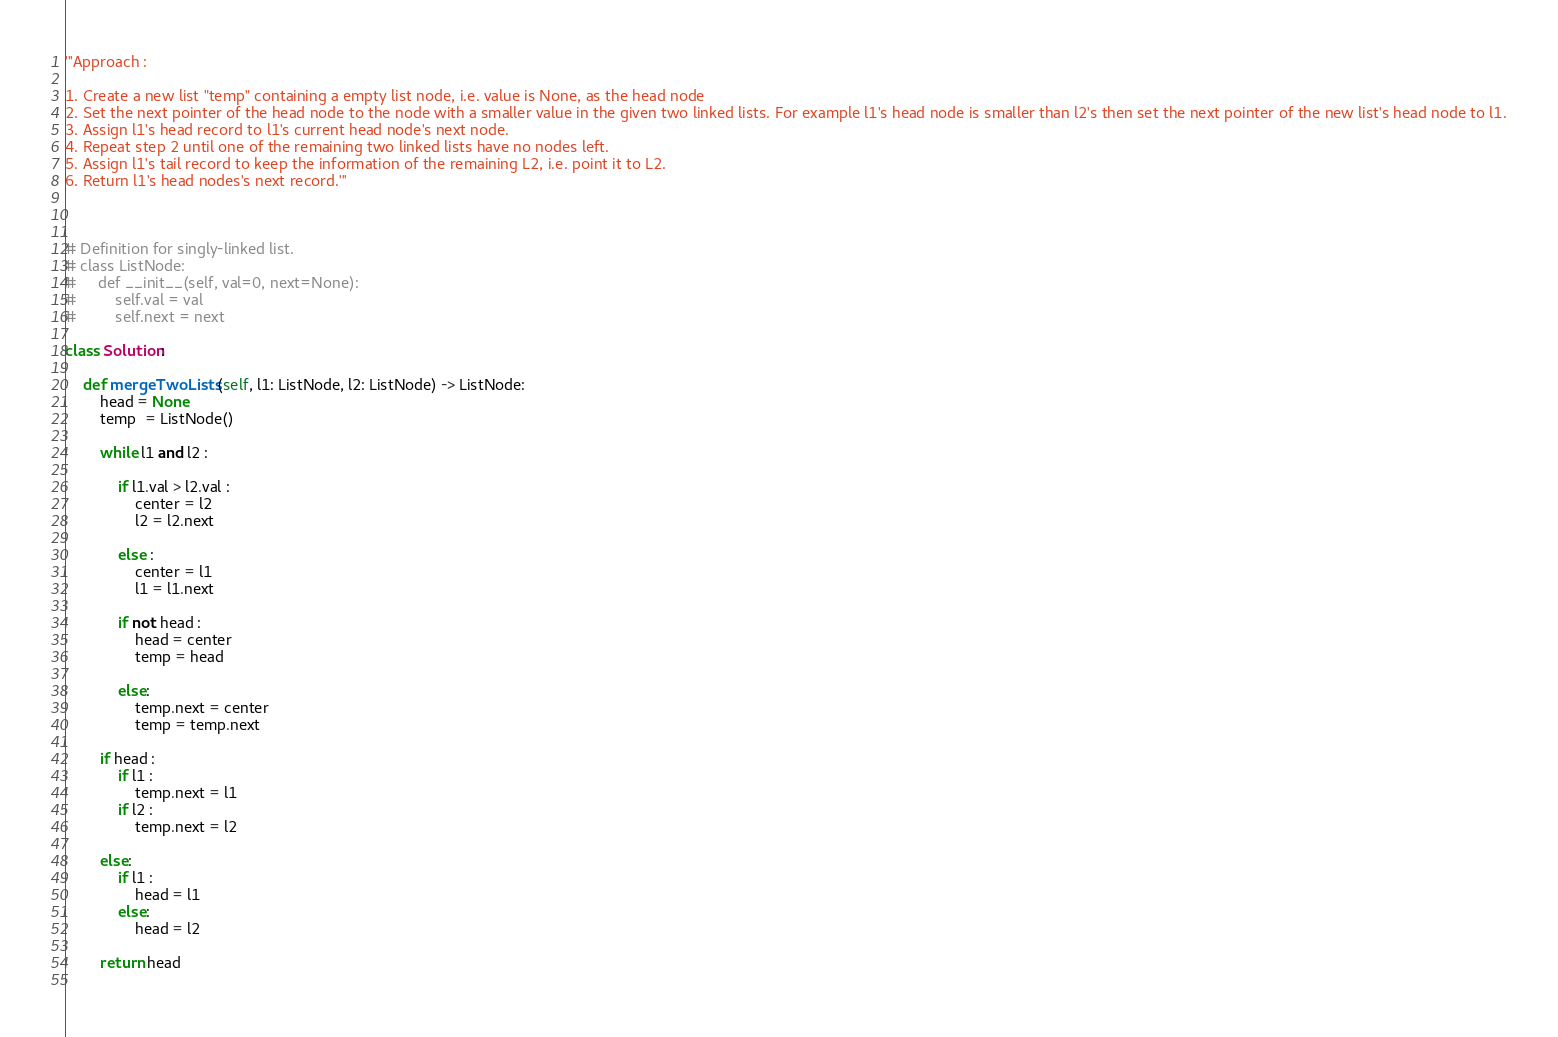<code> <loc_0><loc_0><loc_500><loc_500><_Python_>'''Approach :

1. Create a new list "temp" containing a empty list node, i.e. value is None, as the head node
2. Set the next pointer of the head node to the node with a smaller value in the given two linked lists. For example l1's head node is smaller than l2's then set the next pointer of the new list's head node to l1.
3. Assign l1's head record to l1's current head node's next node.
4. Repeat step 2 until one of the remaining two linked lists have no nodes left.
5. Assign l1's tail record to keep the information of the remaining L2, i.e. point it to L2.
6. Return l1's head nodes's next record.'''



# Definition for singly-linked list.
# class ListNode:
#     def __init__(self, val=0, next=None):
#         self.val = val
#         self.next = next

class Solution:
    
    def mergeTwoLists(self, l1: ListNode, l2: ListNode) -> ListNode:
        head = None
        temp  = ListNode()
        
        while l1 and l2 : 
            
            if l1.val > l2.val : 
                center = l2 
                l2 = l2.next
                
            else : 
                center = l1
                l1 = l1.next
                
            if not head :
                head = center
                temp = head
                
            else: 
                temp.next = center
                temp = temp.next
        
        if head : 
            if l1 : 
                temp.next = l1
            if l2 : 
                temp.next = l2
                
        else: 
            if l1 :
                head = l1
            else:
                head = l2
        
        return head
        </code> 